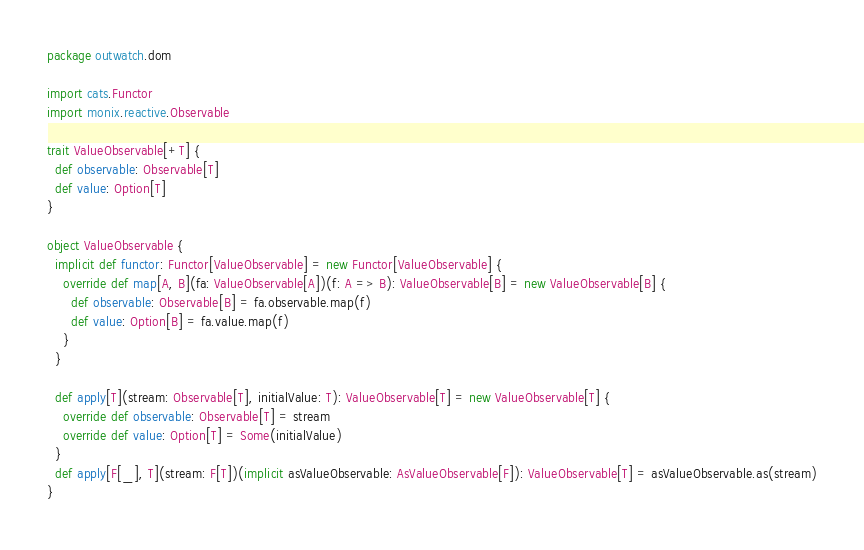<code> <loc_0><loc_0><loc_500><loc_500><_Scala_>package outwatch.dom

import cats.Functor
import monix.reactive.Observable

trait ValueObservable[+T] {
  def observable: Observable[T]
  def value: Option[T]
}

object ValueObservable {
  implicit def functor: Functor[ValueObservable] = new Functor[ValueObservable] {
    override def map[A, B](fa: ValueObservable[A])(f: A => B): ValueObservable[B] = new ValueObservable[B] {
      def observable: Observable[B] = fa.observable.map(f)
      def value: Option[B] = fa.value.map(f)
    }
  }

  def apply[T](stream: Observable[T], initialValue: T): ValueObservable[T] = new ValueObservable[T] {
    override def observable: Observable[T] = stream
    override def value: Option[T] = Some(initialValue)
  }
  def apply[F[_], T](stream: F[T])(implicit asValueObservable: AsValueObservable[F]): ValueObservable[T] = asValueObservable.as(stream)
}
</code> 